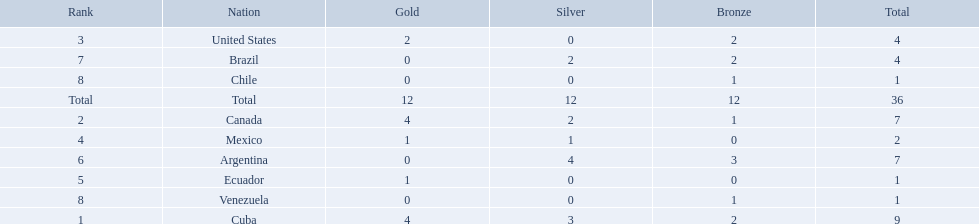Which nations competed in the 2011 pan american games? Cuba, Canada, United States, Mexico, Ecuador, Argentina, Brazil, Chile, Venezuela. Of these nations which ones won gold? Cuba, Canada, United States, Mexico, Ecuador. Which nation of the ones that won gold did not win silver? United States. 